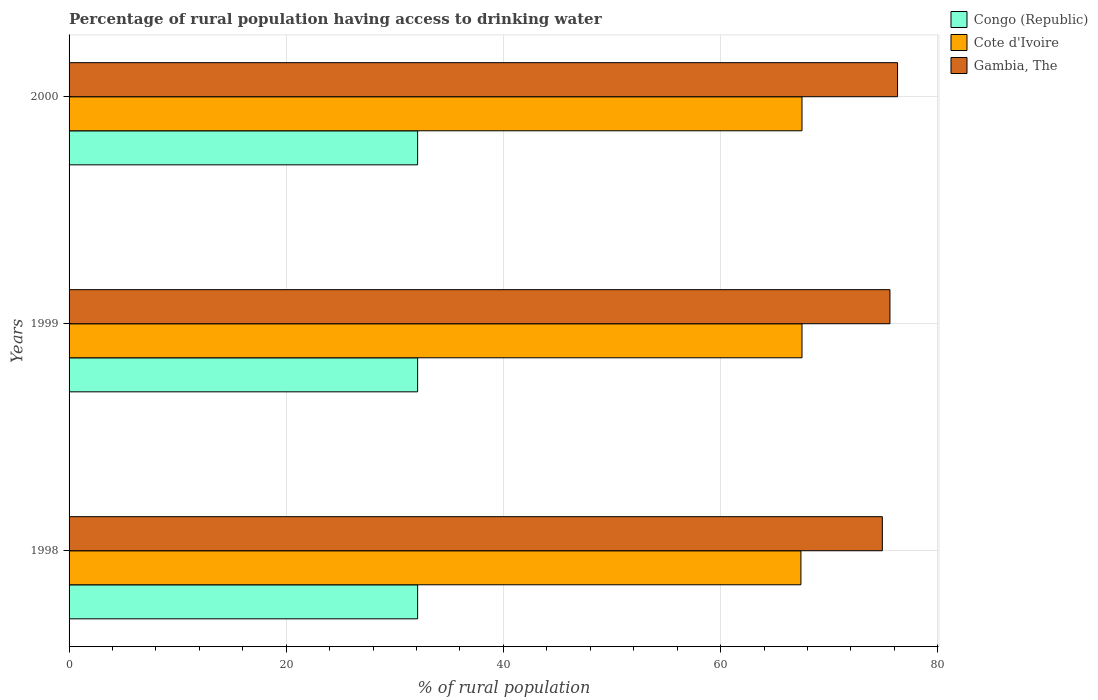How many different coloured bars are there?
Offer a terse response. 3. How many groups of bars are there?
Your response must be concise. 3. Are the number of bars per tick equal to the number of legend labels?
Give a very brief answer. Yes. Are the number of bars on each tick of the Y-axis equal?
Give a very brief answer. Yes. How many bars are there on the 1st tick from the top?
Your answer should be very brief. 3. What is the label of the 1st group of bars from the top?
Offer a very short reply. 2000. In how many cases, is the number of bars for a given year not equal to the number of legend labels?
Give a very brief answer. 0. What is the percentage of rural population having access to drinking water in Gambia, The in 1999?
Keep it short and to the point. 75.6. Across all years, what is the maximum percentage of rural population having access to drinking water in Gambia, The?
Ensure brevity in your answer.  76.3. Across all years, what is the minimum percentage of rural population having access to drinking water in Gambia, The?
Your answer should be compact. 74.9. In which year was the percentage of rural population having access to drinking water in Gambia, The maximum?
Your answer should be compact. 2000. What is the total percentage of rural population having access to drinking water in Gambia, The in the graph?
Provide a short and direct response. 226.8. What is the difference between the percentage of rural population having access to drinking water in Congo (Republic) in 1998 and that in 2000?
Offer a very short reply. 0. What is the difference between the percentage of rural population having access to drinking water in Gambia, The in 1998 and the percentage of rural population having access to drinking water in Congo (Republic) in 1999?
Your answer should be compact. 42.8. What is the average percentage of rural population having access to drinking water in Cote d'Ivoire per year?
Offer a terse response. 67.47. In how many years, is the percentage of rural population having access to drinking water in Gambia, The greater than 8 %?
Offer a terse response. 3. What is the ratio of the percentage of rural population having access to drinking water in Gambia, The in 1999 to that in 2000?
Keep it short and to the point. 0.99. Is the percentage of rural population having access to drinking water in Congo (Republic) in 1998 less than that in 2000?
Your answer should be very brief. No. What is the difference between the highest and the second highest percentage of rural population having access to drinking water in Congo (Republic)?
Your response must be concise. 0. What is the difference between the highest and the lowest percentage of rural population having access to drinking water in Cote d'Ivoire?
Provide a short and direct response. 0.1. What does the 1st bar from the top in 1999 represents?
Give a very brief answer. Gambia, The. What does the 1st bar from the bottom in 1999 represents?
Your answer should be very brief. Congo (Republic). How many bars are there?
Your answer should be compact. 9. What is the difference between two consecutive major ticks on the X-axis?
Your answer should be very brief. 20. Does the graph contain any zero values?
Make the answer very short. No. Where does the legend appear in the graph?
Provide a short and direct response. Top right. What is the title of the graph?
Provide a short and direct response. Percentage of rural population having access to drinking water. What is the label or title of the X-axis?
Give a very brief answer. % of rural population. What is the % of rural population of Congo (Republic) in 1998?
Make the answer very short. 32.1. What is the % of rural population in Cote d'Ivoire in 1998?
Give a very brief answer. 67.4. What is the % of rural population of Gambia, The in 1998?
Provide a short and direct response. 74.9. What is the % of rural population in Congo (Republic) in 1999?
Provide a succinct answer. 32.1. What is the % of rural population of Cote d'Ivoire in 1999?
Ensure brevity in your answer.  67.5. What is the % of rural population in Gambia, The in 1999?
Your answer should be very brief. 75.6. What is the % of rural population in Congo (Republic) in 2000?
Give a very brief answer. 32.1. What is the % of rural population of Cote d'Ivoire in 2000?
Your answer should be very brief. 67.5. What is the % of rural population in Gambia, The in 2000?
Ensure brevity in your answer.  76.3. Across all years, what is the maximum % of rural population in Congo (Republic)?
Provide a succinct answer. 32.1. Across all years, what is the maximum % of rural population in Cote d'Ivoire?
Keep it short and to the point. 67.5. Across all years, what is the maximum % of rural population of Gambia, The?
Offer a very short reply. 76.3. Across all years, what is the minimum % of rural population in Congo (Republic)?
Provide a short and direct response. 32.1. Across all years, what is the minimum % of rural population in Cote d'Ivoire?
Give a very brief answer. 67.4. Across all years, what is the minimum % of rural population in Gambia, The?
Ensure brevity in your answer.  74.9. What is the total % of rural population of Congo (Republic) in the graph?
Keep it short and to the point. 96.3. What is the total % of rural population of Cote d'Ivoire in the graph?
Your answer should be compact. 202.4. What is the total % of rural population in Gambia, The in the graph?
Your answer should be compact. 226.8. What is the difference between the % of rural population in Congo (Republic) in 1998 and that in 1999?
Your answer should be compact. 0. What is the difference between the % of rural population in Cote d'Ivoire in 1998 and that in 1999?
Your answer should be compact. -0.1. What is the difference between the % of rural population in Gambia, The in 1998 and that in 2000?
Your response must be concise. -1.4. What is the difference between the % of rural population of Cote d'Ivoire in 1999 and that in 2000?
Your answer should be very brief. 0. What is the difference between the % of rural population of Congo (Republic) in 1998 and the % of rural population of Cote d'Ivoire in 1999?
Keep it short and to the point. -35.4. What is the difference between the % of rural population in Congo (Republic) in 1998 and the % of rural population in Gambia, The in 1999?
Offer a terse response. -43.5. What is the difference between the % of rural population in Congo (Republic) in 1998 and the % of rural population in Cote d'Ivoire in 2000?
Provide a succinct answer. -35.4. What is the difference between the % of rural population in Congo (Republic) in 1998 and the % of rural population in Gambia, The in 2000?
Your response must be concise. -44.2. What is the difference between the % of rural population of Cote d'Ivoire in 1998 and the % of rural population of Gambia, The in 2000?
Give a very brief answer. -8.9. What is the difference between the % of rural population in Congo (Republic) in 1999 and the % of rural population in Cote d'Ivoire in 2000?
Provide a succinct answer. -35.4. What is the difference between the % of rural population in Congo (Republic) in 1999 and the % of rural population in Gambia, The in 2000?
Your answer should be compact. -44.2. What is the average % of rural population in Congo (Republic) per year?
Give a very brief answer. 32.1. What is the average % of rural population of Cote d'Ivoire per year?
Your answer should be very brief. 67.47. What is the average % of rural population in Gambia, The per year?
Provide a short and direct response. 75.6. In the year 1998, what is the difference between the % of rural population in Congo (Republic) and % of rural population in Cote d'Ivoire?
Provide a succinct answer. -35.3. In the year 1998, what is the difference between the % of rural population of Congo (Republic) and % of rural population of Gambia, The?
Offer a terse response. -42.8. In the year 1999, what is the difference between the % of rural population of Congo (Republic) and % of rural population of Cote d'Ivoire?
Keep it short and to the point. -35.4. In the year 1999, what is the difference between the % of rural population of Congo (Republic) and % of rural population of Gambia, The?
Offer a very short reply. -43.5. In the year 2000, what is the difference between the % of rural population of Congo (Republic) and % of rural population of Cote d'Ivoire?
Offer a terse response. -35.4. In the year 2000, what is the difference between the % of rural population of Congo (Republic) and % of rural population of Gambia, The?
Offer a very short reply. -44.2. What is the ratio of the % of rural population in Gambia, The in 1998 to that in 1999?
Your response must be concise. 0.99. What is the ratio of the % of rural population of Congo (Republic) in 1998 to that in 2000?
Keep it short and to the point. 1. What is the ratio of the % of rural population in Cote d'Ivoire in 1998 to that in 2000?
Your answer should be compact. 1. What is the ratio of the % of rural population in Gambia, The in 1998 to that in 2000?
Make the answer very short. 0.98. What is the ratio of the % of rural population of Cote d'Ivoire in 1999 to that in 2000?
Keep it short and to the point. 1. What is the ratio of the % of rural population of Gambia, The in 1999 to that in 2000?
Offer a terse response. 0.99. What is the difference between the highest and the second highest % of rural population of Cote d'Ivoire?
Your answer should be very brief. 0. What is the difference between the highest and the second highest % of rural population in Gambia, The?
Your answer should be compact. 0.7. What is the difference between the highest and the lowest % of rural population in Congo (Republic)?
Offer a terse response. 0. 